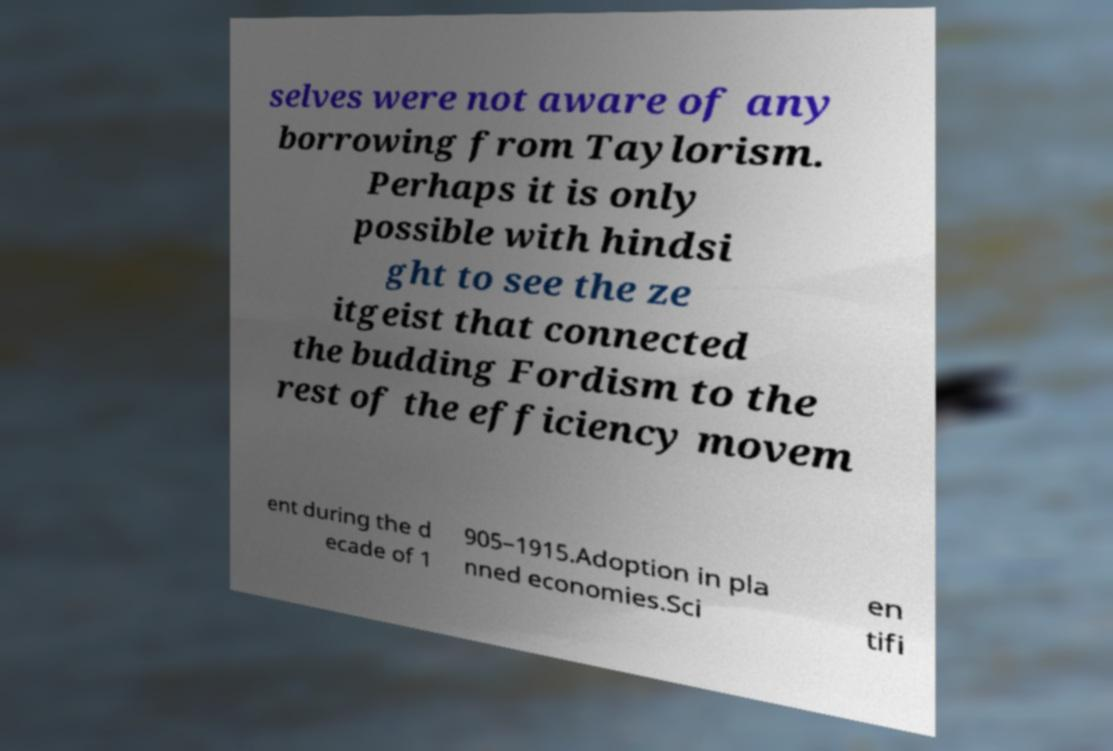Please read and relay the text visible in this image. What does it say? selves were not aware of any borrowing from Taylorism. Perhaps it is only possible with hindsi ght to see the ze itgeist that connected the budding Fordism to the rest of the efficiency movem ent during the d ecade of 1 905–1915.Adoption in pla nned economies.Sci en tifi 